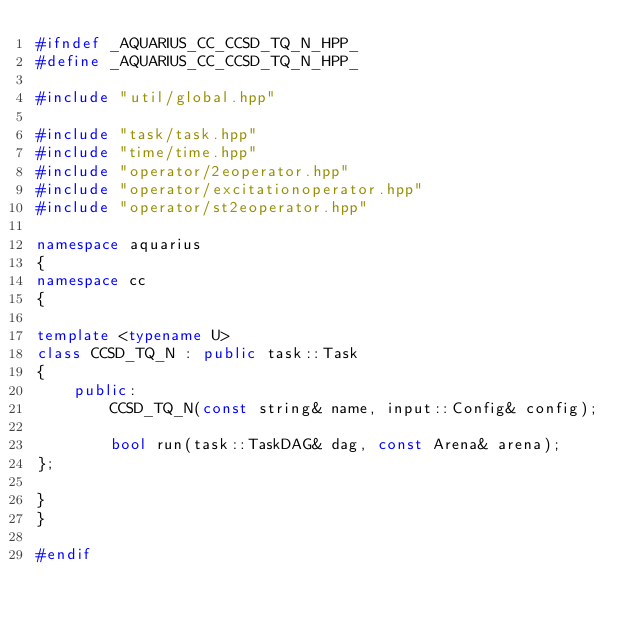Convert code to text. <code><loc_0><loc_0><loc_500><loc_500><_C++_>#ifndef _AQUARIUS_CC_CCSD_TQ_N_HPP_
#define _AQUARIUS_CC_CCSD_TQ_N_HPP_

#include "util/global.hpp"

#include "task/task.hpp"
#include "time/time.hpp"
#include "operator/2eoperator.hpp"
#include "operator/excitationoperator.hpp"
#include "operator/st2eoperator.hpp"

namespace aquarius
{
namespace cc
{

template <typename U>
class CCSD_TQ_N : public task::Task
{
    public:
        CCSD_TQ_N(const string& name, input::Config& config);

        bool run(task::TaskDAG& dag, const Arena& arena);
};

}
}

#endif
</code> 